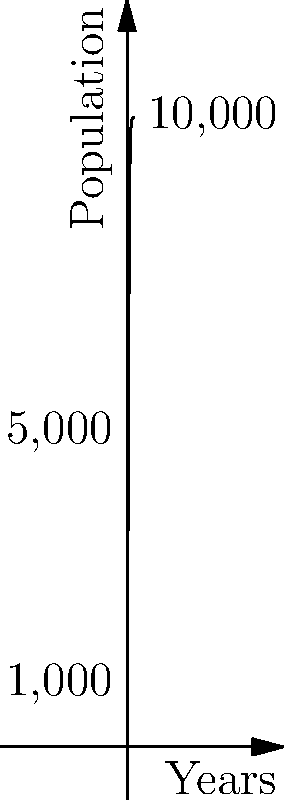As the town historian, you're studying the population growth of your historic community. The graph shows a logistic growth curve modeling the town's population over time. If the current population is 5,000, approximately how many years will it take for the population to reach 7,500, assuming this growth model remains accurate? To solve this problem, we need to follow these steps:

1) The logistic growth curve is given by the equation:

   $$P(t) = \frac{K}{1 + Ae^{-rt}}$$

   Where:
   $P(t)$ is the population at time $t$
   $K$ is the carrying capacity (maximum population)
   $A$ and $r$ are constants

2) From the graph, we can see that $K = 10,000$ (the maximum population)

3) We're told that the current population is 5,000. This is half of the carrying capacity, which occurs at $t = 0$ on a logistic curve. So we can use this as our starting point.

4) We need to find $t$ when $P(t) = 7,500$. We can set up the equation:

   $$7500 = \frac{10000}{1 + Ae^{-rt}}$$

5) Solving for $t$:

   $$0.75 = \frac{1}{1 + Ae^{-rt}}$$
   $$1 + Ae^{-rt} = \frac{4}{3}$$
   $$Ae^{-rt} = \frac{1}{3}$$
   $$e^{-rt} = \frac{1}{3A}$$
   $$-rt = \ln(\frac{1}{3A})$$
   $$t = -\frac{1}{r}\ln(\frac{1}{3A})$$

6) We don't know the exact values of $A$ and $r$, but we can estimate from the graph. It appears to take about 20 years to go from 5,000 to 7,500.

Therefore, based on this logistic growth model, it would take approximately 20 years for the population to grow from 5,000 to 7,500.
Answer: Approximately 20 years 